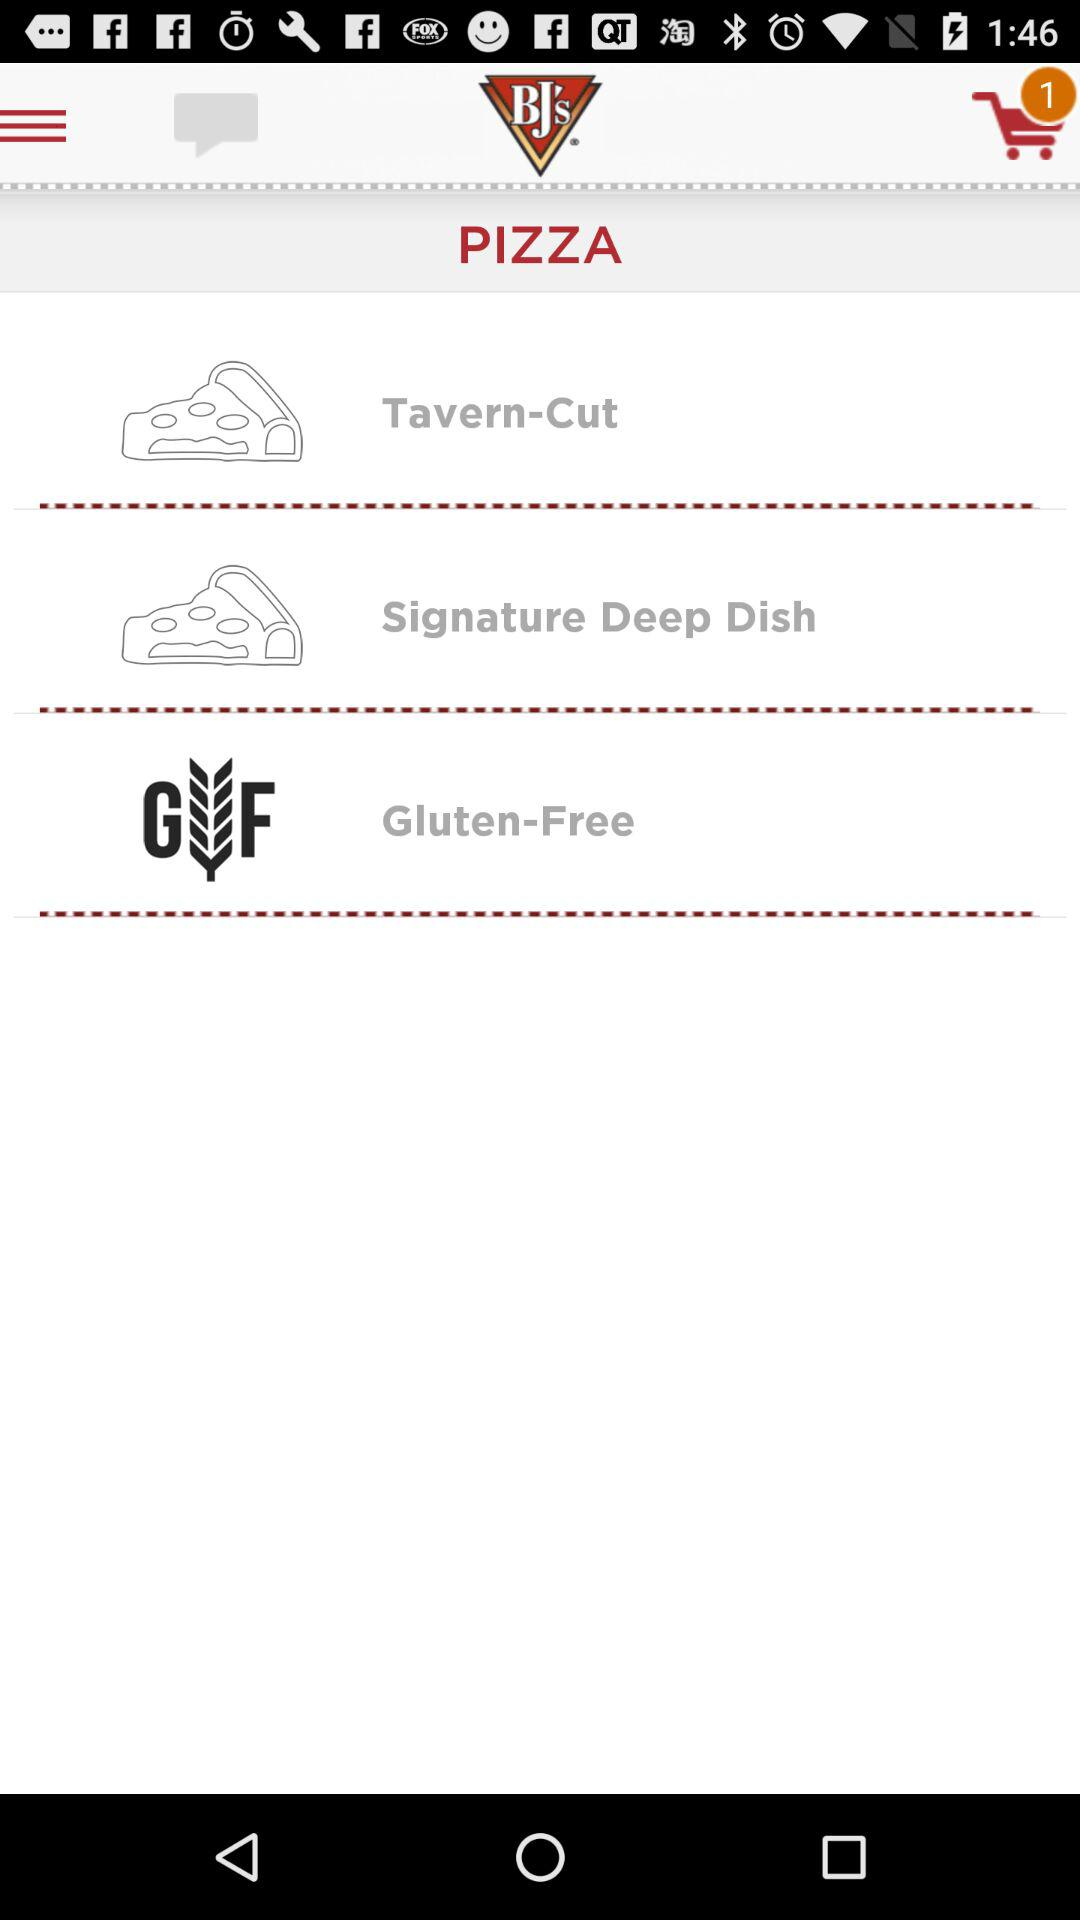How many pizza options are gluten-free?
Answer the question using a single word or phrase. 1 